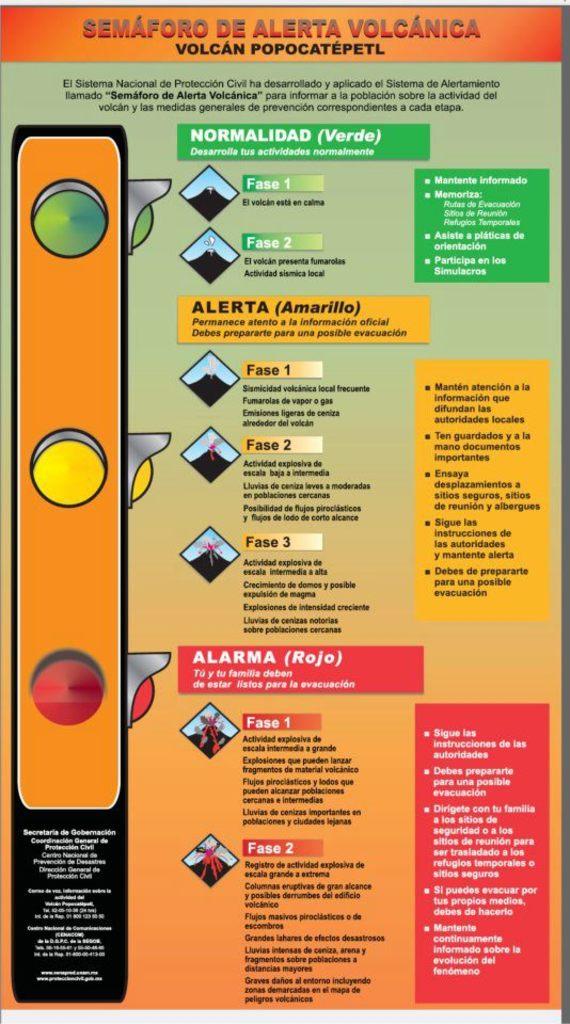What's the title of the poster?
Your response must be concise. Semaforo de alerta volcanica. 